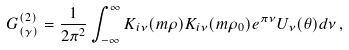<formula> <loc_0><loc_0><loc_500><loc_500>G ^ { ( 2 ) } _ { ( \gamma ) } = \frac { 1 } { 2 \pi ^ { 2 } } \int _ { - \infty } ^ { \infty } K _ { i \nu } ( m \rho ) K _ { i \nu } ( m \rho _ { 0 } ) e ^ { \pi \nu } U _ { \nu } ( \theta ) d \nu \, ,</formula> 